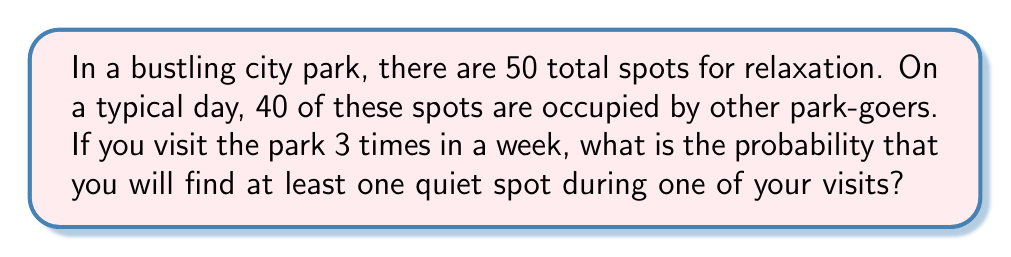Can you answer this question? Let's approach this step-by-step:

1) First, let's calculate the probability of finding a quiet spot on a single visit:
   
   Probability of a quiet spot = $\frac{\text{Number of quiet spots}}{\text{Total number of spots}}$ = $\frac{50-40}{50}$ = $\frac{10}{50}$ = $\frac{1}{5}$ = 0.2

2) Now, let's calculate the probability of not finding a quiet spot on a single visit:
   
   Probability of no quiet spot = 1 - Probability of a quiet spot = 1 - 0.2 = 0.8

3) For three independent visits, the probability of not finding a quiet spot on any visit is:
   
   $$(0.8)^3 = 0.512$$

4) Therefore, the probability of finding at least one quiet spot during the three visits is:
   
   $$1 - (0.8)^3 = 1 - 0.512 = 0.488$$

5) Converting to a percentage:
   
   $$0.488 \times 100\% = 48.8\%$$
Answer: 48.8% 